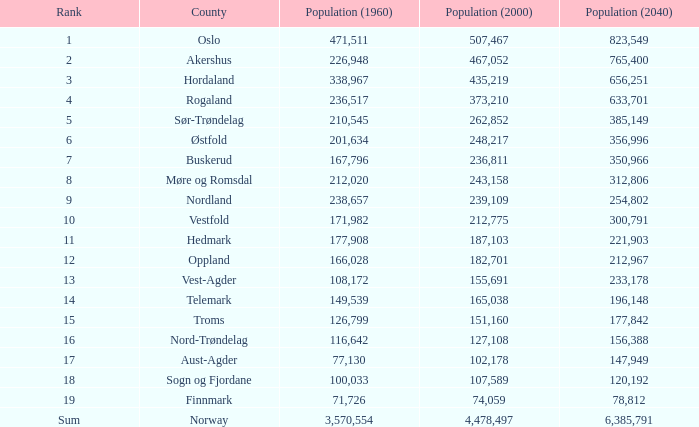What was the population of a county in 2040 that had a population less than 108,172 in 2000 and less than 107,589 in 1960? 2.0. 